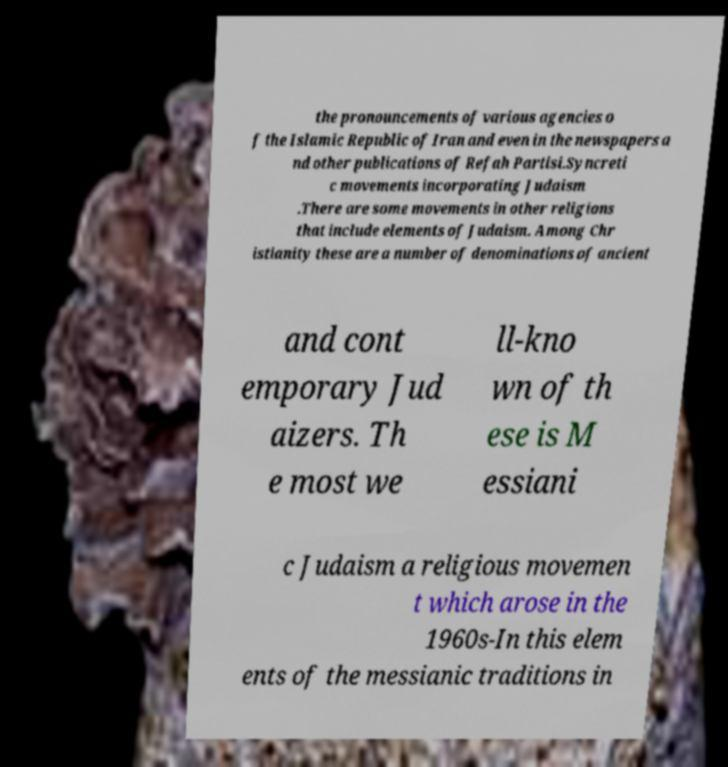I need the written content from this picture converted into text. Can you do that? the pronouncements of various agencies o f the Islamic Republic of Iran and even in the newspapers a nd other publications of Refah Partisi.Syncreti c movements incorporating Judaism .There are some movements in other religions that include elements of Judaism. Among Chr istianity these are a number of denominations of ancient and cont emporary Jud aizers. Th e most we ll-kno wn of th ese is M essiani c Judaism a religious movemen t which arose in the 1960s-In this elem ents of the messianic traditions in 